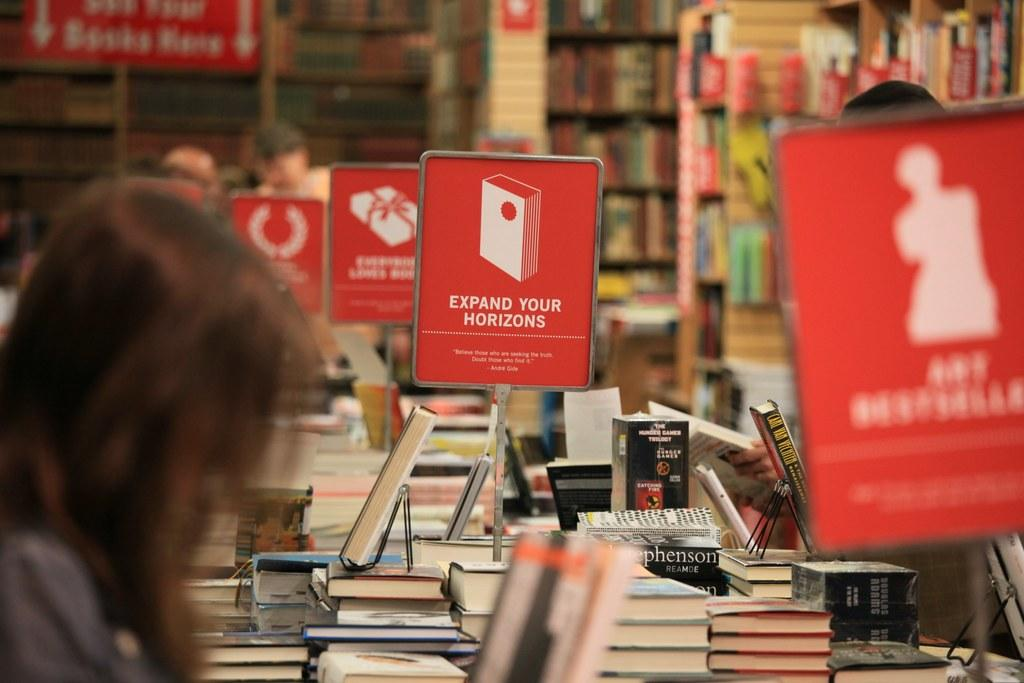<image>
Give a short and clear explanation of the subsequent image. A sign on a bookstore table offers a suggestion to "expand your horizons," followed by an Andre Gide quote. 